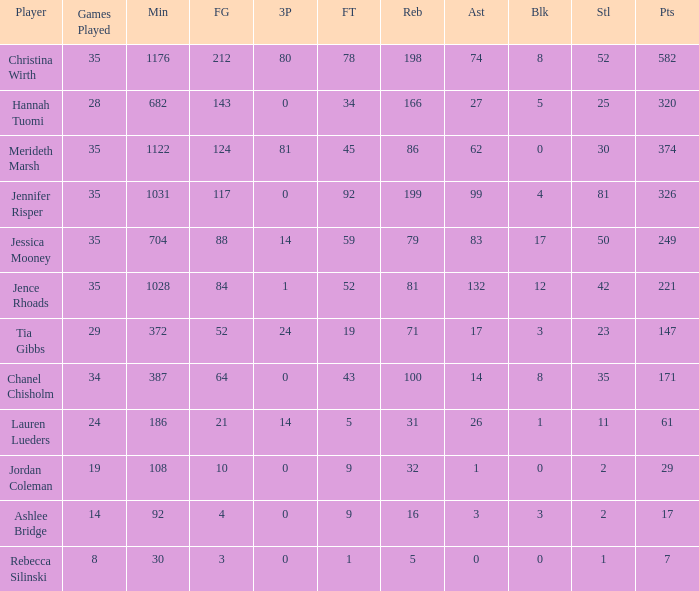How much time, in minutes, did Chanel Chisholm play? 1.0. 